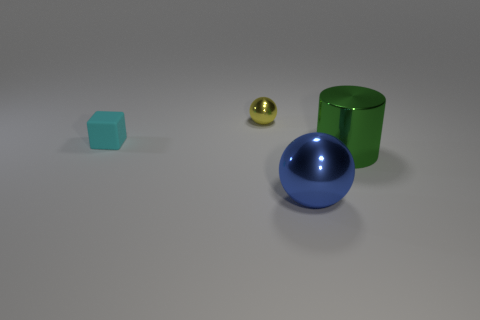Subtract all cylinders. How many objects are left? 3 Subtract 1 cylinders. How many cylinders are left? 0 Add 4 large green things. How many objects exist? 8 Subtract all brown blocks. Subtract all red cylinders. How many blocks are left? 1 Subtract all brown metallic objects. Subtract all large things. How many objects are left? 2 Add 3 blocks. How many blocks are left? 4 Add 4 gray metallic things. How many gray metallic things exist? 4 Subtract 0 cyan cylinders. How many objects are left? 4 